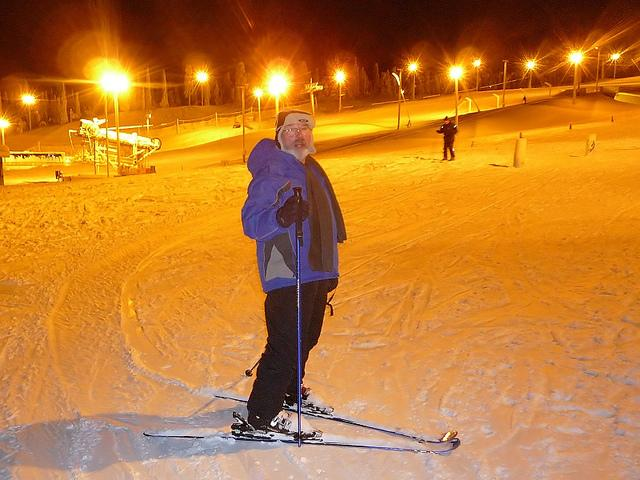Why is the man wearing a hat with earflaps?

Choices:
A) warmth
B) visibility
C) as cosplay
D) fashion warmth 